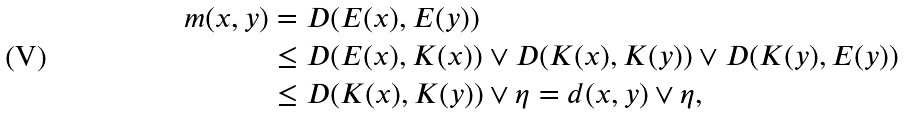<formula> <loc_0><loc_0><loc_500><loc_500>m ( x , y ) & = D ( E ( x ) , E ( y ) ) \\ & \leq D ( E ( x ) , K ( x ) ) \lor D ( K ( x ) , K ( y ) ) \lor D ( K ( y ) , E ( y ) ) \\ & \leq D ( K ( x ) , K ( y ) ) \lor \eta = d ( x , y ) \lor \eta ,</formula> 